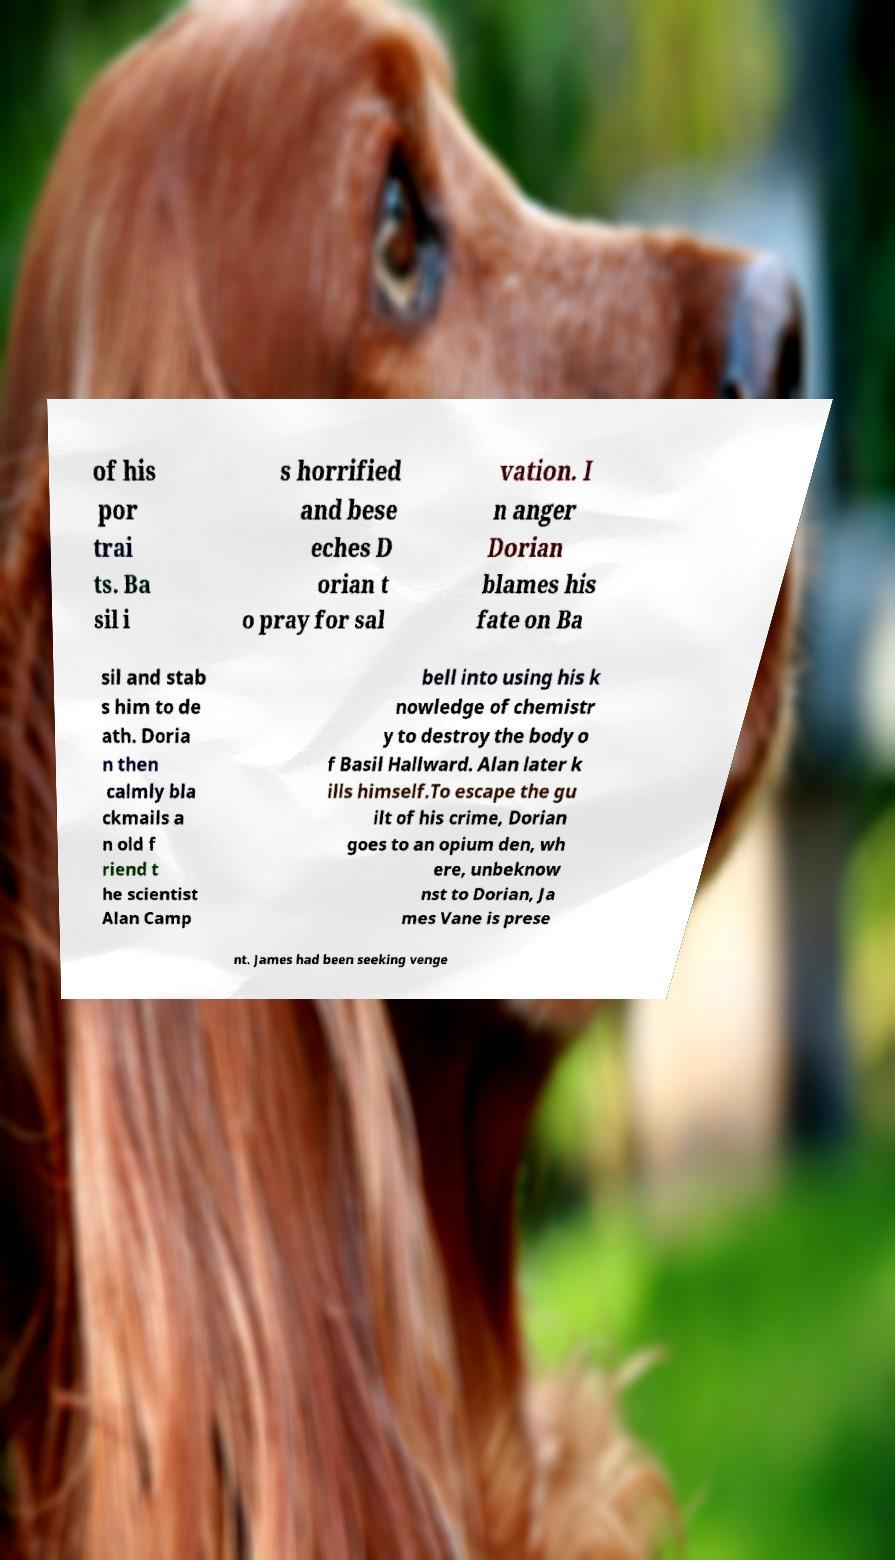What messages or text are displayed in this image? I need them in a readable, typed format. of his por trai ts. Ba sil i s horrified and bese eches D orian t o pray for sal vation. I n anger Dorian blames his fate on Ba sil and stab s him to de ath. Doria n then calmly bla ckmails a n old f riend t he scientist Alan Camp bell into using his k nowledge of chemistr y to destroy the body o f Basil Hallward. Alan later k ills himself.To escape the gu ilt of his crime, Dorian goes to an opium den, wh ere, unbeknow nst to Dorian, Ja mes Vane is prese nt. James had been seeking venge 